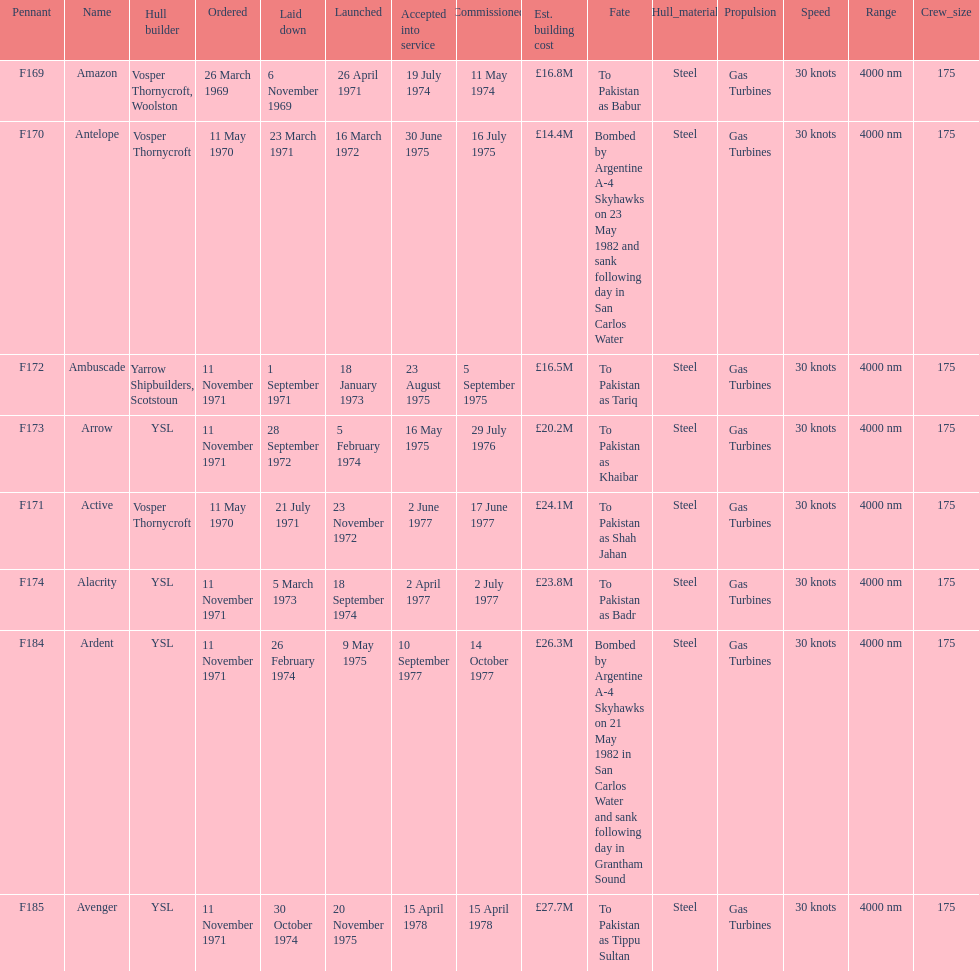How many boats costed less than £20m to build? 3. 